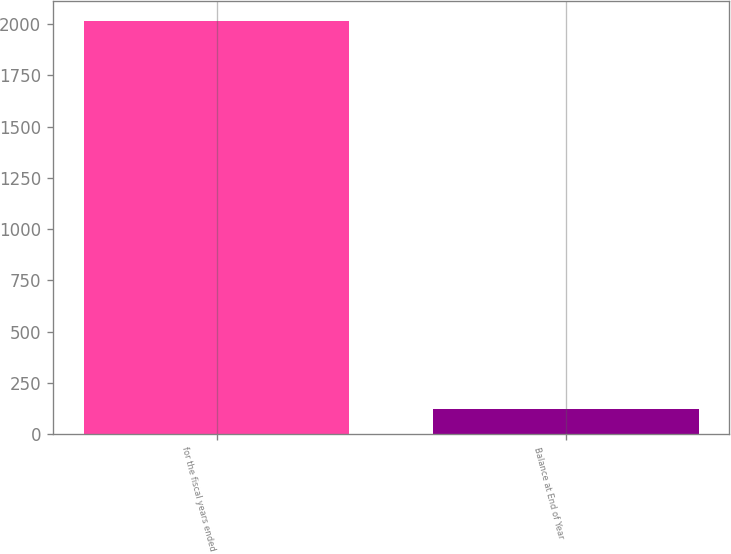Convert chart to OTSL. <chart><loc_0><loc_0><loc_500><loc_500><bar_chart><fcel>for the fiscal years ended<fcel>Balance at End of Year<nl><fcel>2013<fcel>121.8<nl></chart> 